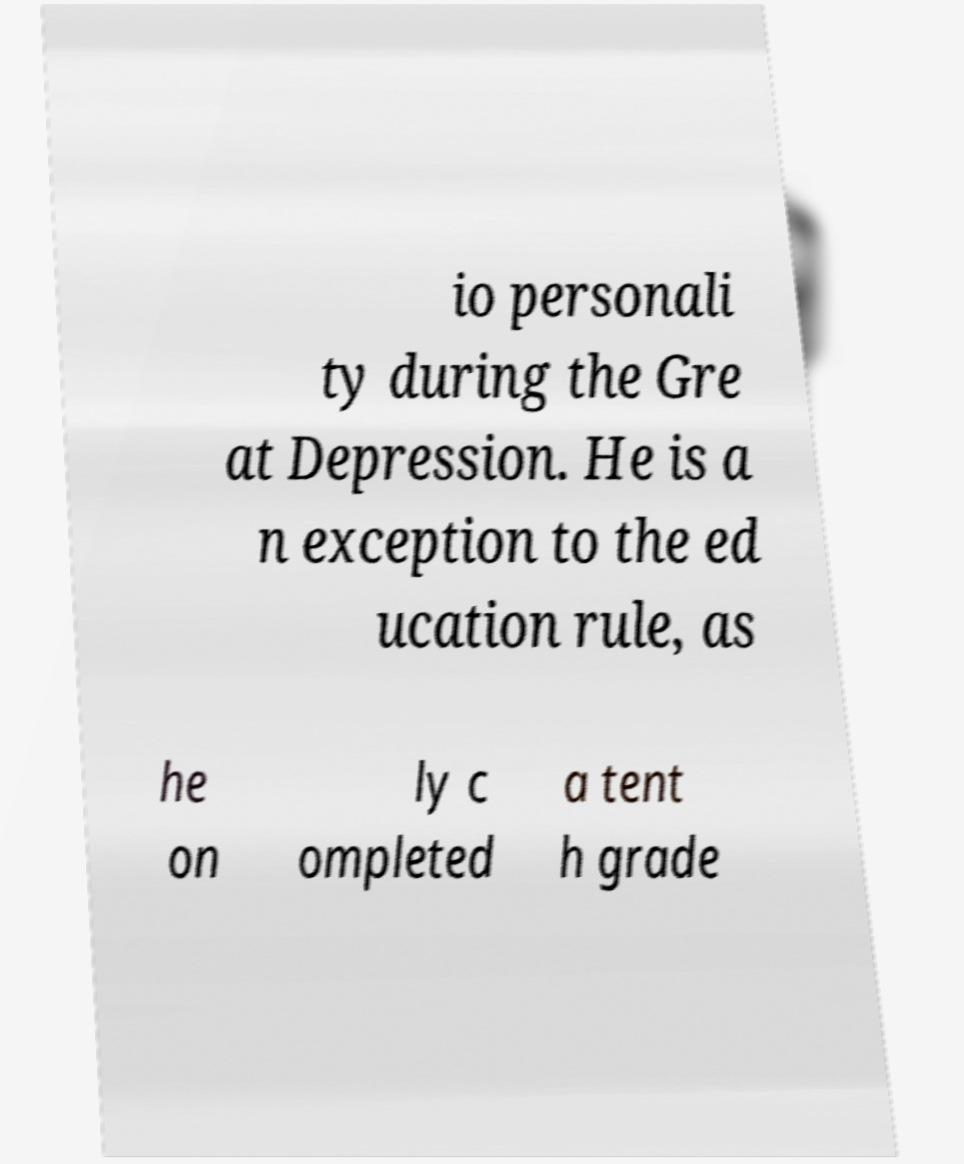I need the written content from this picture converted into text. Can you do that? io personali ty during the Gre at Depression. He is a n exception to the ed ucation rule, as he on ly c ompleted a tent h grade 